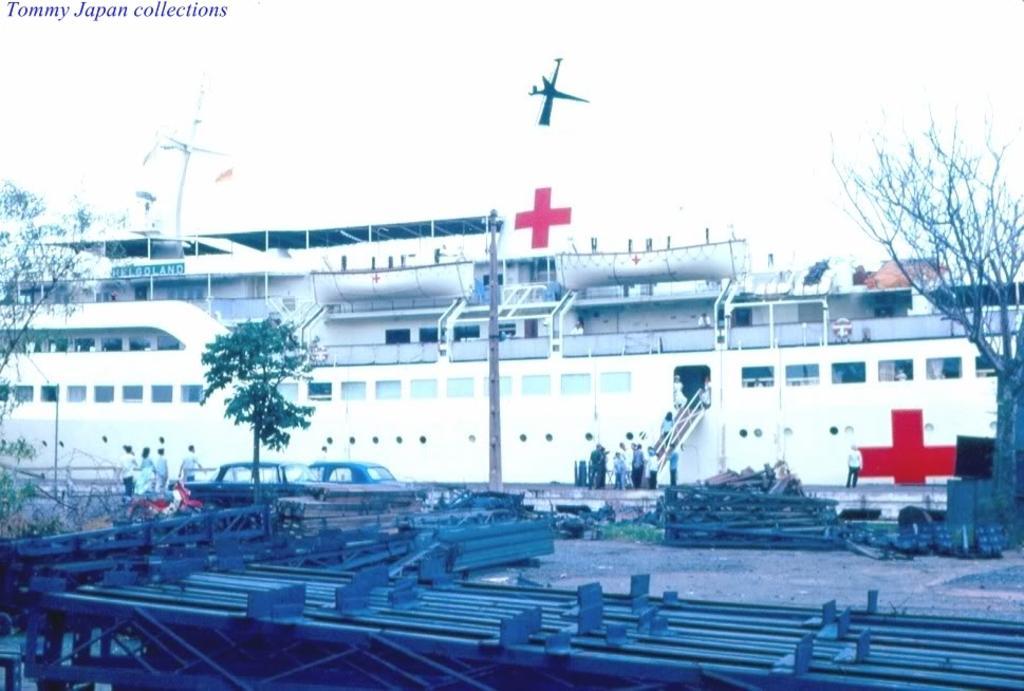Can you describe this image briefly? In this image at the bottom we can see metal objects on the ground, trees and few persons. In the background we can see a ship, windows, poles, few persons standing at the steps and on the steps, vehicles, name board on the ship, plus symbol and sky. 